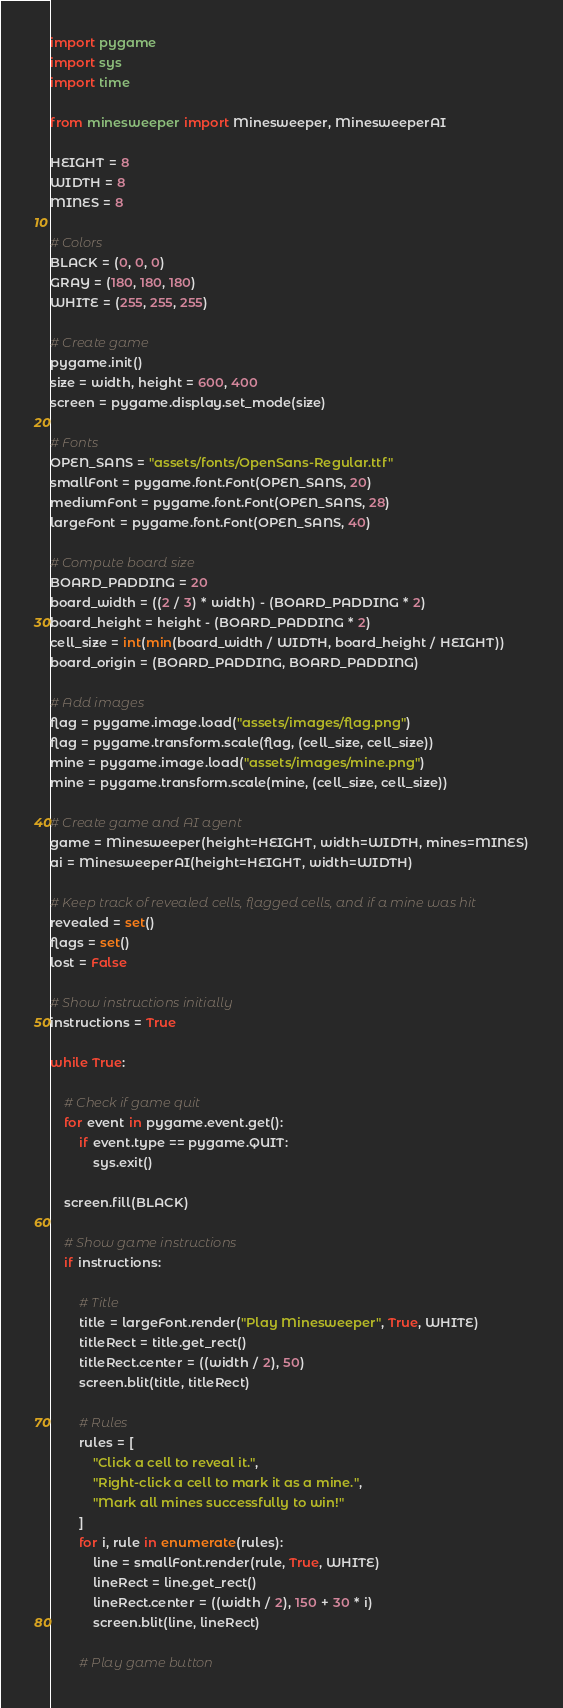Convert code to text. <code><loc_0><loc_0><loc_500><loc_500><_Python_>import pygame
import sys
import time

from minesweeper import Minesweeper, MinesweeperAI

HEIGHT = 8
WIDTH = 8
MINES = 8

# Colors
BLACK = (0, 0, 0)
GRAY = (180, 180, 180)
WHITE = (255, 255, 255)

# Create game
pygame.init()
size = width, height = 600, 400
screen = pygame.display.set_mode(size)

# Fonts
OPEN_SANS = "assets/fonts/OpenSans-Regular.ttf"
smallFont = pygame.font.Font(OPEN_SANS, 20)
mediumFont = pygame.font.Font(OPEN_SANS, 28)
largeFont = pygame.font.Font(OPEN_SANS, 40)

# Compute board size
BOARD_PADDING = 20
board_width = ((2 / 3) * width) - (BOARD_PADDING * 2)
board_height = height - (BOARD_PADDING * 2)
cell_size = int(min(board_width / WIDTH, board_height / HEIGHT))
board_origin = (BOARD_PADDING, BOARD_PADDING)

# Add images
flag = pygame.image.load("assets/images/flag.png")
flag = pygame.transform.scale(flag, (cell_size, cell_size))
mine = pygame.image.load("assets/images/mine.png")
mine = pygame.transform.scale(mine, (cell_size, cell_size))

# Create game and AI agent
game = Minesweeper(height=HEIGHT, width=WIDTH, mines=MINES)
ai = MinesweeperAI(height=HEIGHT, width=WIDTH)

# Keep track of revealed cells, flagged cells, and if a mine was hit
revealed = set()
flags = set()
lost = False

# Show instructions initially
instructions = True

while True:

    # Check if game quit
    for event in pygame.event.get():
        if event.type == pygame.QUIT:
            sys.exit()

    screen.fill(BLACK)

    # Show game instructions
    if instructions:

        # Title
        title = largeFont.render("Play Minesweeper", True, WHITE)
        titleRect = title.get_rect()
        titleRect.center = ((width / 2), 50)
        screen.blit(title, titleRect)

        # Rules
        rules = [
            "Click a cell to reveal it.",
            "Right-click a cell to mark it as a mine.",
            "Mark all mines successfully to win!"
        ]
        for i, rule in enumerate(rules):
            line = smallFont.render(rule, True, WHITE)
            lineRect = line.get_rect()
            lineRect.center = ((width / 2), 150 + 30 * i)
            screen.blit(line, lineRect)

        # Play game button</code> 